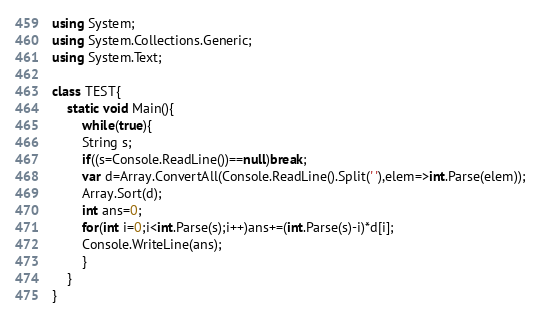<code> <loc_0><loc_0><loc_500><loc_500><_C#_>using System;
using System.Collections.Generic;
using System.Text;

class TEST{
	static void Main(){
		while(true){
		String s;
		if((s=Console.ReadLine())==null)break;
		var d=Array.ConvertAll(Console.ReadLine().Split(' '),elem=>int.Parse(elem));
		Array.Sort(d);
		int ans=0;
		for(int i=0;i<int.Parse(s);i++)ans+=(int.Parse(s)-i)*d[i];
		Console.WriteLine(ans);
		}
	}
}</code> 